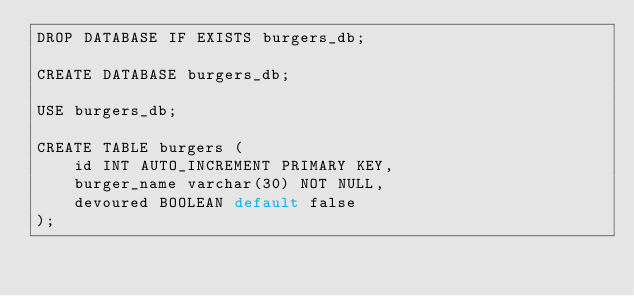<code> <loc_0><loc_0><loc_500><loc_500><_SQL_>DROP DATABASE IF EXISTS burgers_db;

CREATE DATABASE burgers_db;

USE burgers_db;

CREATE TABLE burgers (
    id INT AUTO_INCREMENT PRIMARY KEY,
    burger_name varchar(30) NOT NULL,
    devoured BOOLEAN default false
);
</code> 